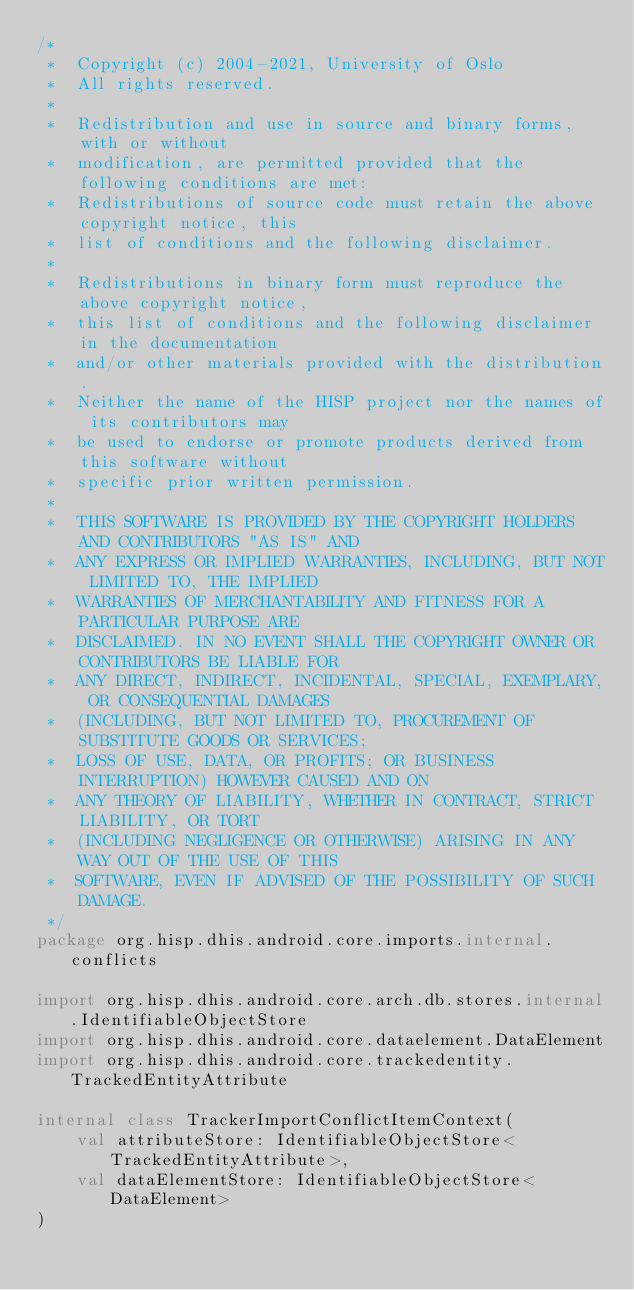Convert code to text. <code><loc_0><loc_0><loc_500><loc_500><_Kotlin_>/*
 *  Copyright (c) 2004-2021, University of Oslo
 *  All rights reserved.
 *
 *  Redistribution and use in source and binary forms, with or without
 *  modification, are permitted provided that the following conditions are met:
 *  Redistributions of source code must retain the above copyright notice, this
 *  list of conditions and the following disclaimer.
 *
 *  Redistributions in binary form must reproduce the above copyright notice,
 *  this list of conditions and the following disclaimer in the documentation
 *  and/or other materials provided with the distribution.
 *  Neither the name of the HISP project nor the names of its contributors may
 *  be used to endorse or promote products derived from this software without
 *  specific prior written permission.
 *
 *  THIS SOFTWARE IS PROVIDED BY THE COPYRIGHT HOLDERS AND CONTRIBUTORS "AS IS" AND
 *  ANY EXPRESS OR IMPLIED WARRANTIES, INCLUDING, BUT NOT LIMITED TO, THE IMPLIED
 *  WARRANTIES OF MERCHANTABILITY AND FITNESS FOR A PARTICULAR PURPOSE ARE
 *  DISCLAIMED. IN NO EVENT SHALL THE COPYRIGHT OWNER OR CONTRIBUTORS BE LIABLE FOR
 *  ANY DIRECT, INDIRECT, INCIDENTAL, SPECIAL, EXEMPLARY, OR CONSEQUENTIAL DAMAGES
 *  (INCLUDING, BUT NOT LIMITED TO, PROCUREMENT OF SUBSTITUTE GOODS OR SERVICES;
 *  LOSS OF USE, DATA, OR PROFITS; OR BUSINESS INTERRUPTION) HOWEVER CAUSED AND ON
 *  ANY THEORY OF LIABILITY, WHETHER IN CONTRACT, STRICT LIABILITY, OR TORT
 *  (INCLUDING NEGLIGENCE OR OTHERWISE) ARISING IN ANY WAY OUT OF THE USE OF THIS
 *  SOFTWARE, EVEN IF ADVISED OF THE POSSIBILITY OF SUCH DAMAGE.
 */
package org.hisp.dhis.android.core.imports.internal.conflicts

import org.hisp.dhis.android.core.arch.db.stores.internal.IdentifiableObjectStore
import org.hisp.dhis.android.core.dataelement.DataElement
import org.hisp.dhis.android.core.trackedentity.TrackedEntityAttribute

internal class TrackerImportConflictItemContext(
    val attributeStore: IdentifiableObjectStore<TrackedEntityAttribute>,
    val dataElementStore: IdentifiableObjectStore<DataElement>
)
</code> 